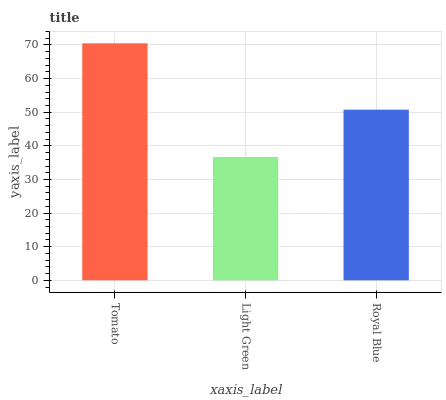Is Light Green the minimum?
Answer yes or no. Yes. Is Tomato the maximum?
Answer yes or no. Yes. Is Royal Blue the minimum?
Answer yes or no. No. Is Royal Blue the maximum?
Answer yes or no. No. Is Royal Blue greater than Light Green?
Answer yes or no. Yes. Is Light Green less than Royal Blue?
Answer yes or no. Yes. Is Light Green greater than Royal Blue?
Answer yes or no. No. Is Royal Blue less than Light Green?
Answer yes or no. No. Is Royal Blue the high median?
Answer yes or no. Yes. Is Royal Blue the low median?
Answer yes or no. Yes. Is Light Green the high median?
Answer yes or no. No. Is Tomato the low median?
Answer yes or no. No. 